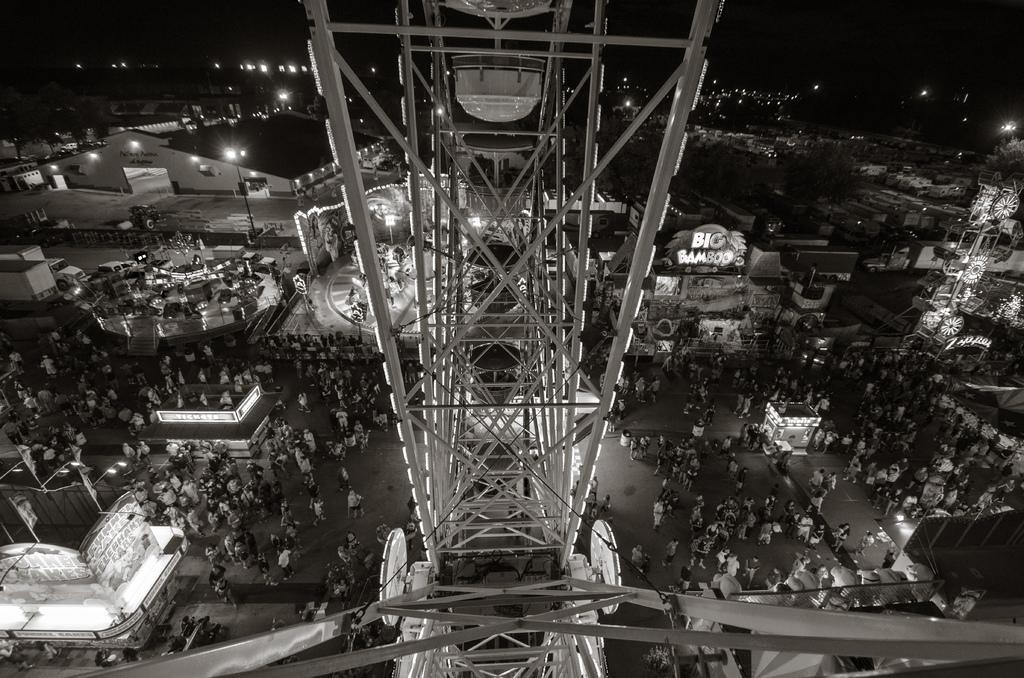Describe this image in one or two sentences. In this image we can see so many buildings, shops, lights, one antenna, some poles and name boards. Some vehicles are parked in a parking area and some vehicles are on the road. So many people are there, some people standing and some people are sitting. 